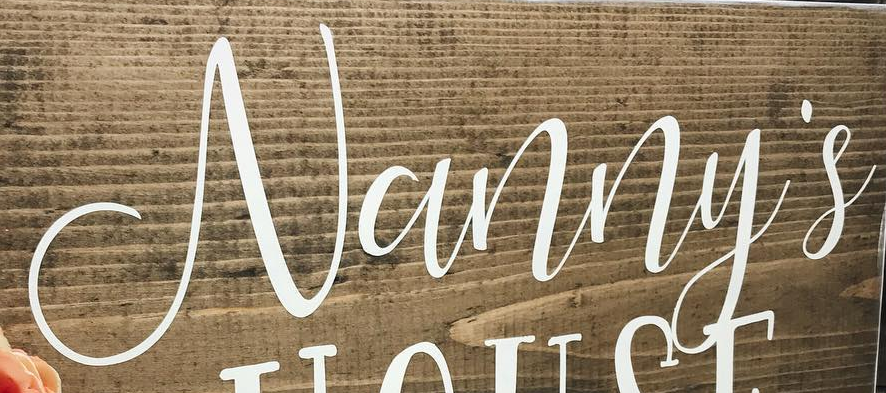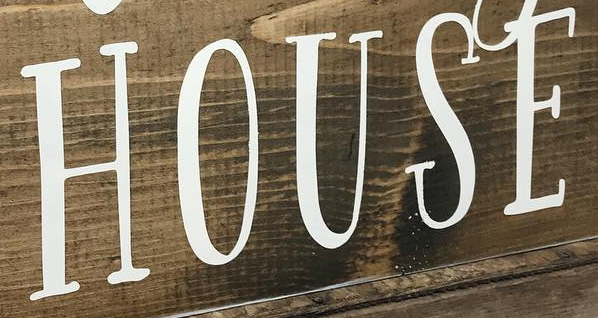Read the text content from these images in order, separated by a semicolon. Vanny's; HOUSE 